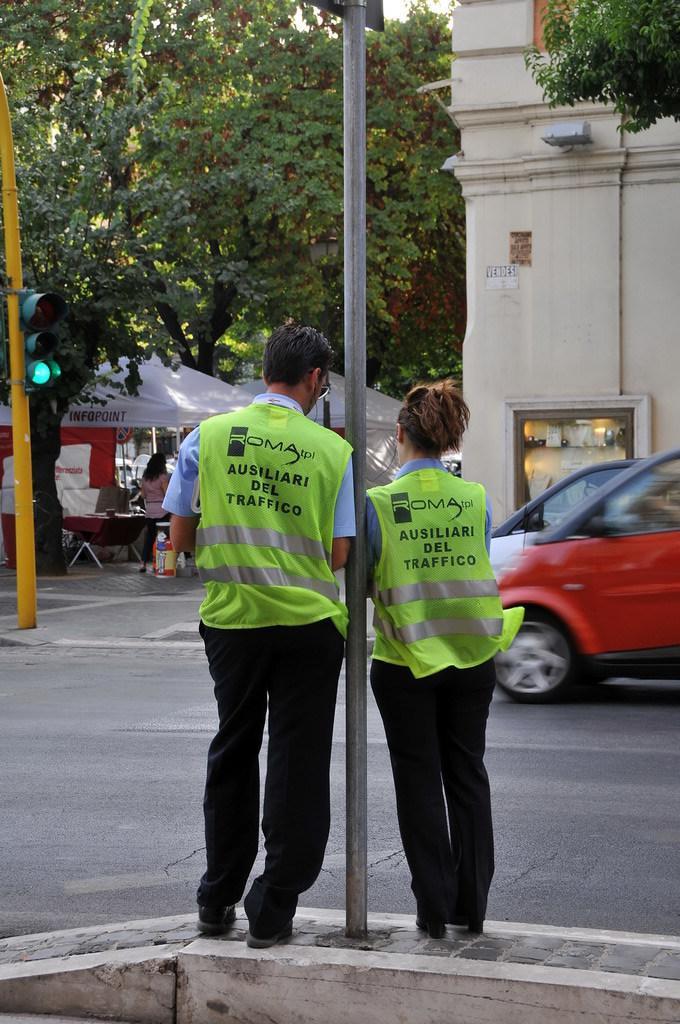Describe this image in one or two sentences. This picture is clicked outside the city. The man and the woman in the uniform are standing beside the pole. In front of them, we see cars moving on the road. Beside cars, we see a building in white color. On the left side of the picture, we see traffic signals. In the background, there are trees and tents in white color. 